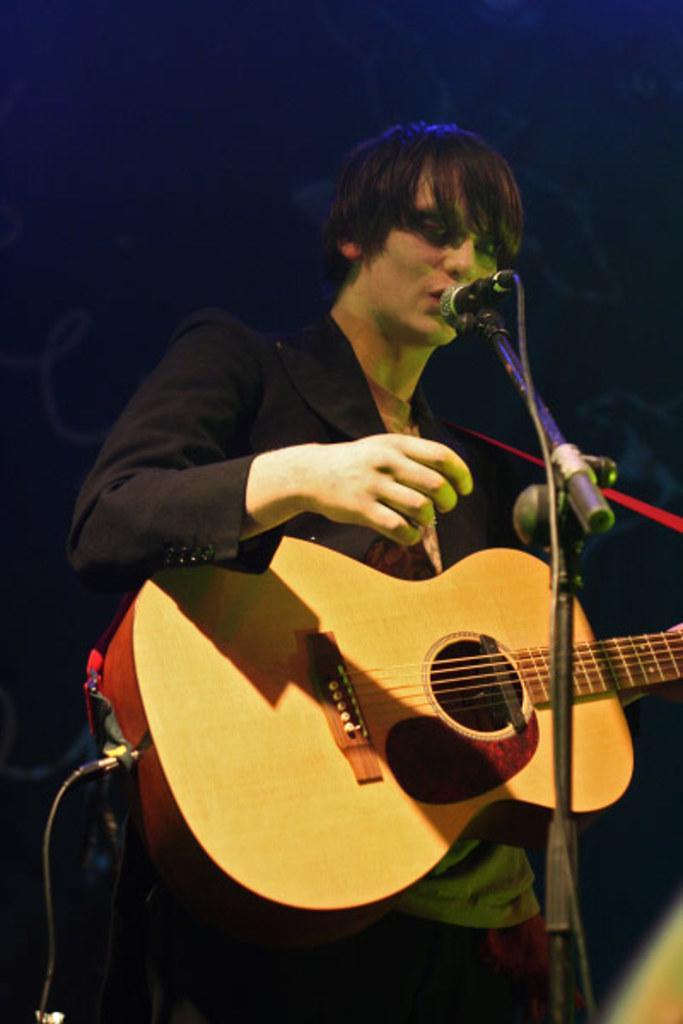Can you describe this image briefly? The image consists of a man with black suit playing a guitar and singing on mic. 